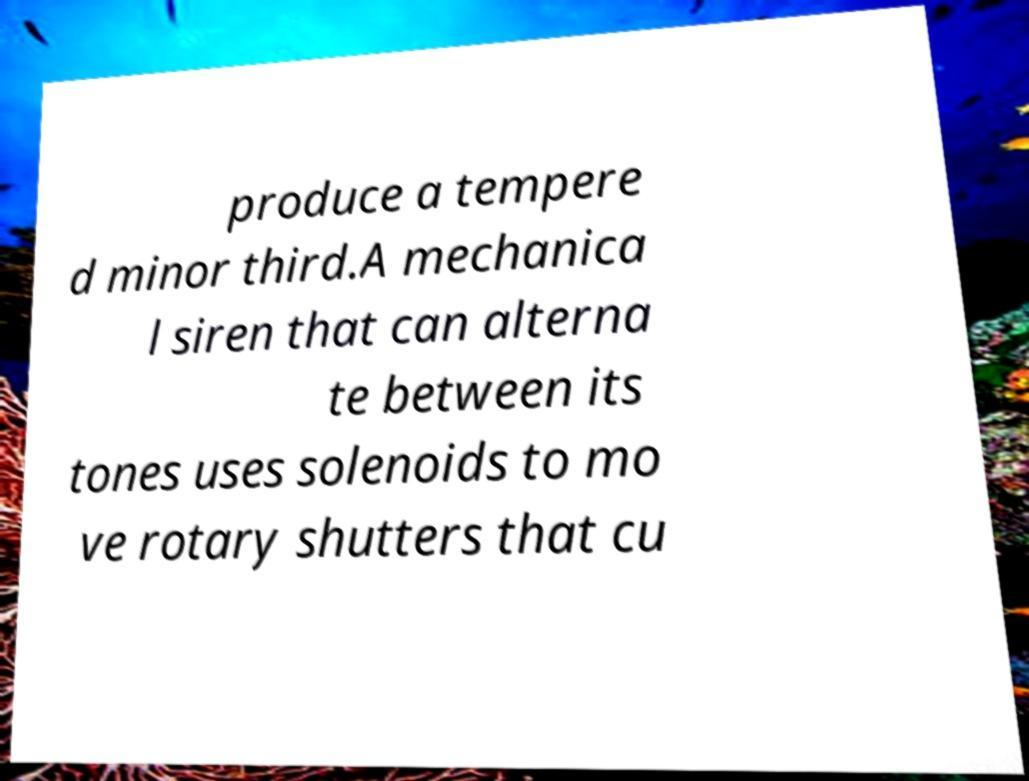Could you extract and type out the text from this image? produce a tempere d minor third.A mechanica l siren that can alterna te between its tones uses solenoids to mo ve rotary shutters that cu 